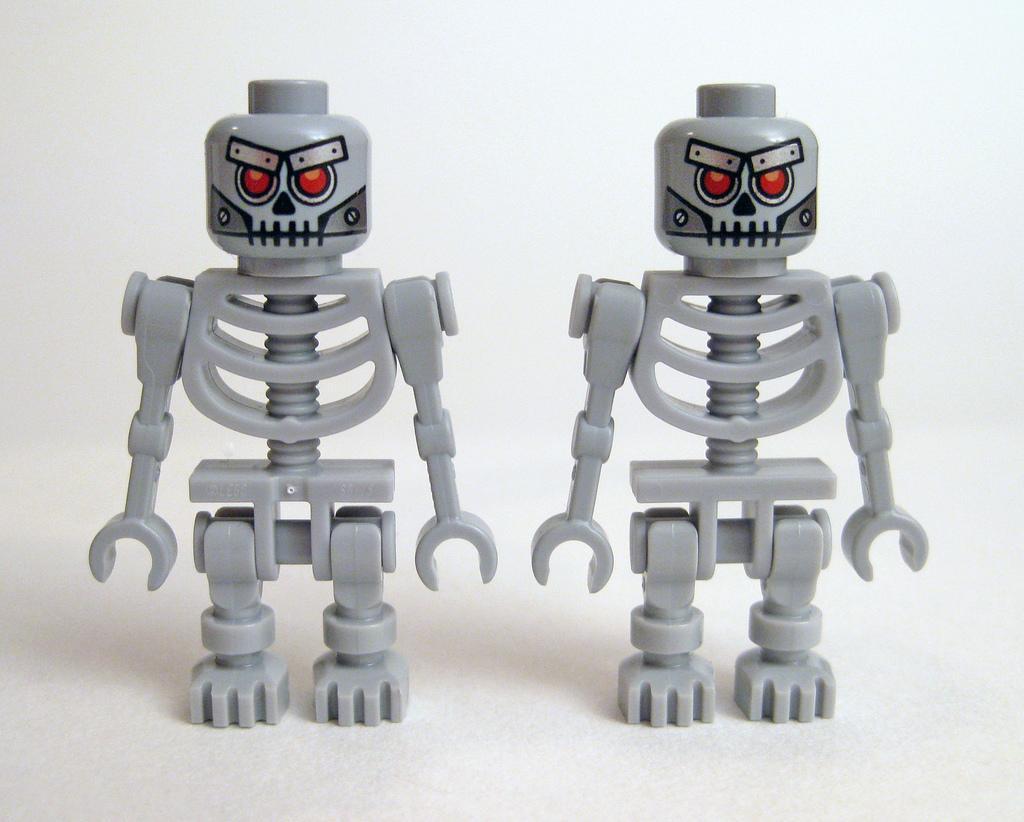Can you describe this image briefly? In this picture we can see two toys. 